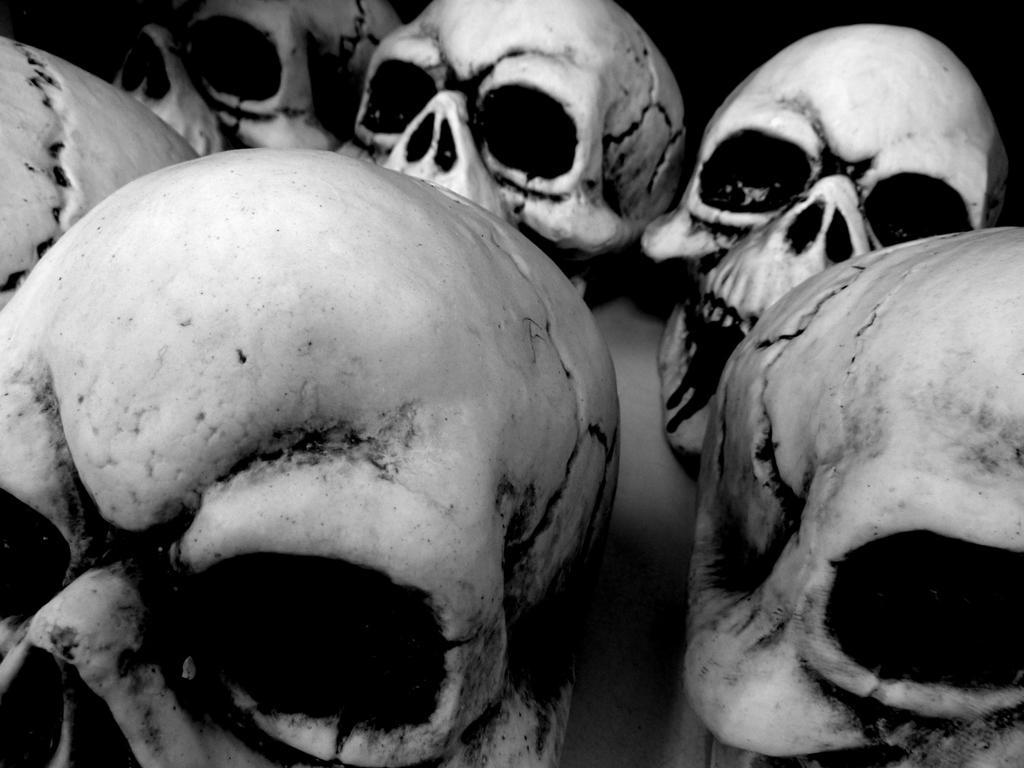Describe this image in one or two sentences. In the picture we can see some human skulls. 